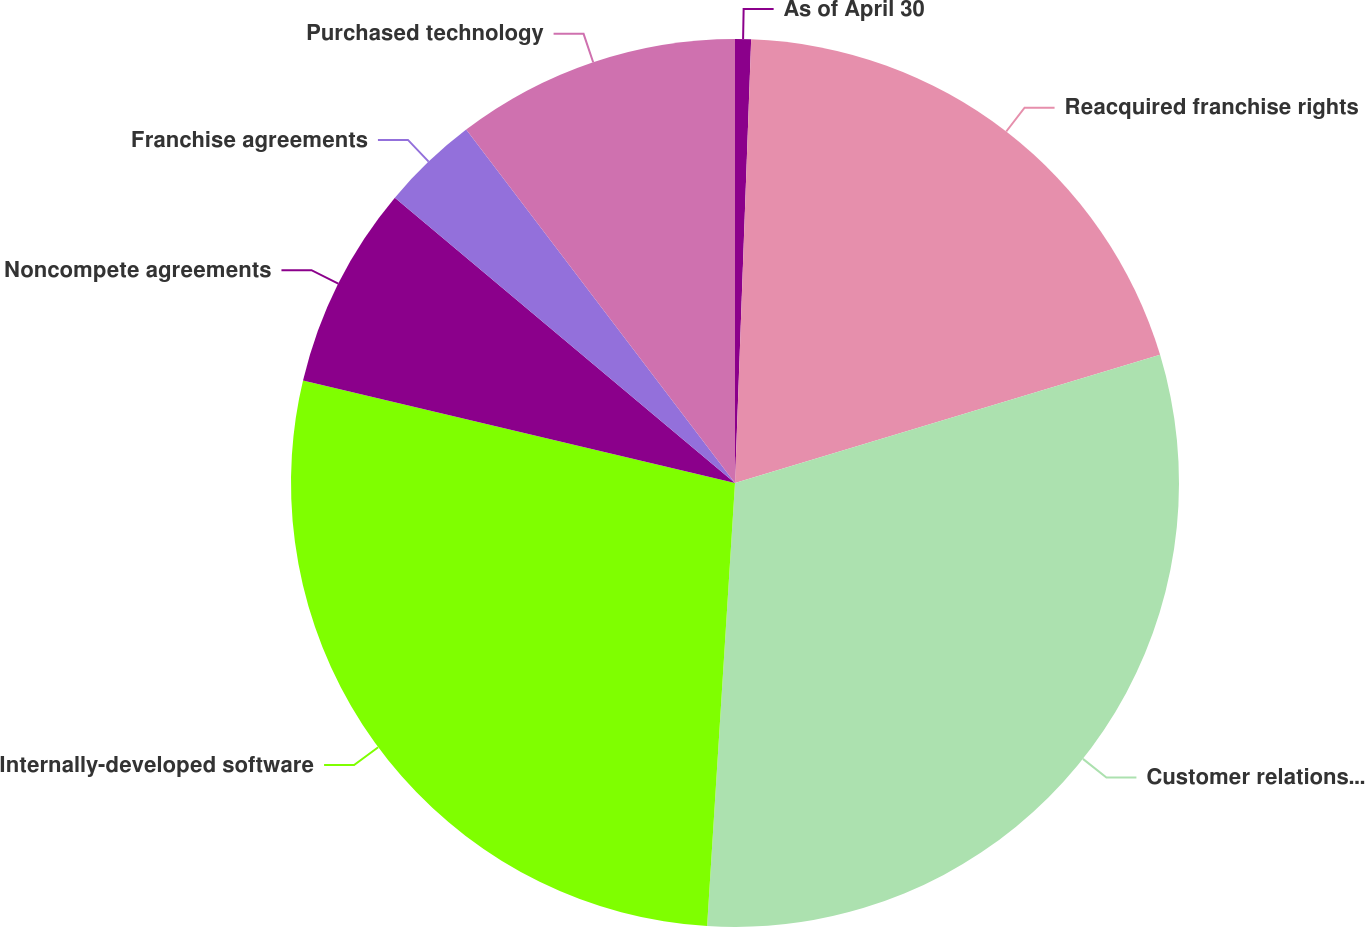<chart> <loc_0><loc_0><loc_500><loc_500><pie_chart><fcel>As of April 30<fcel>Reacquired franchise rights<fcel>Customer relationships<fcel>Internally-developed software<fcel>Noncompete agreements<fcel>Franchise agreements<fcel>Purchased technology<nl><fcel>0.58%<fcel>19.76%<fcel>30.66%<fcel>27.71%<fcel>7.4%<fcel>3.54%<fcel>10.35%<nl></chart> 